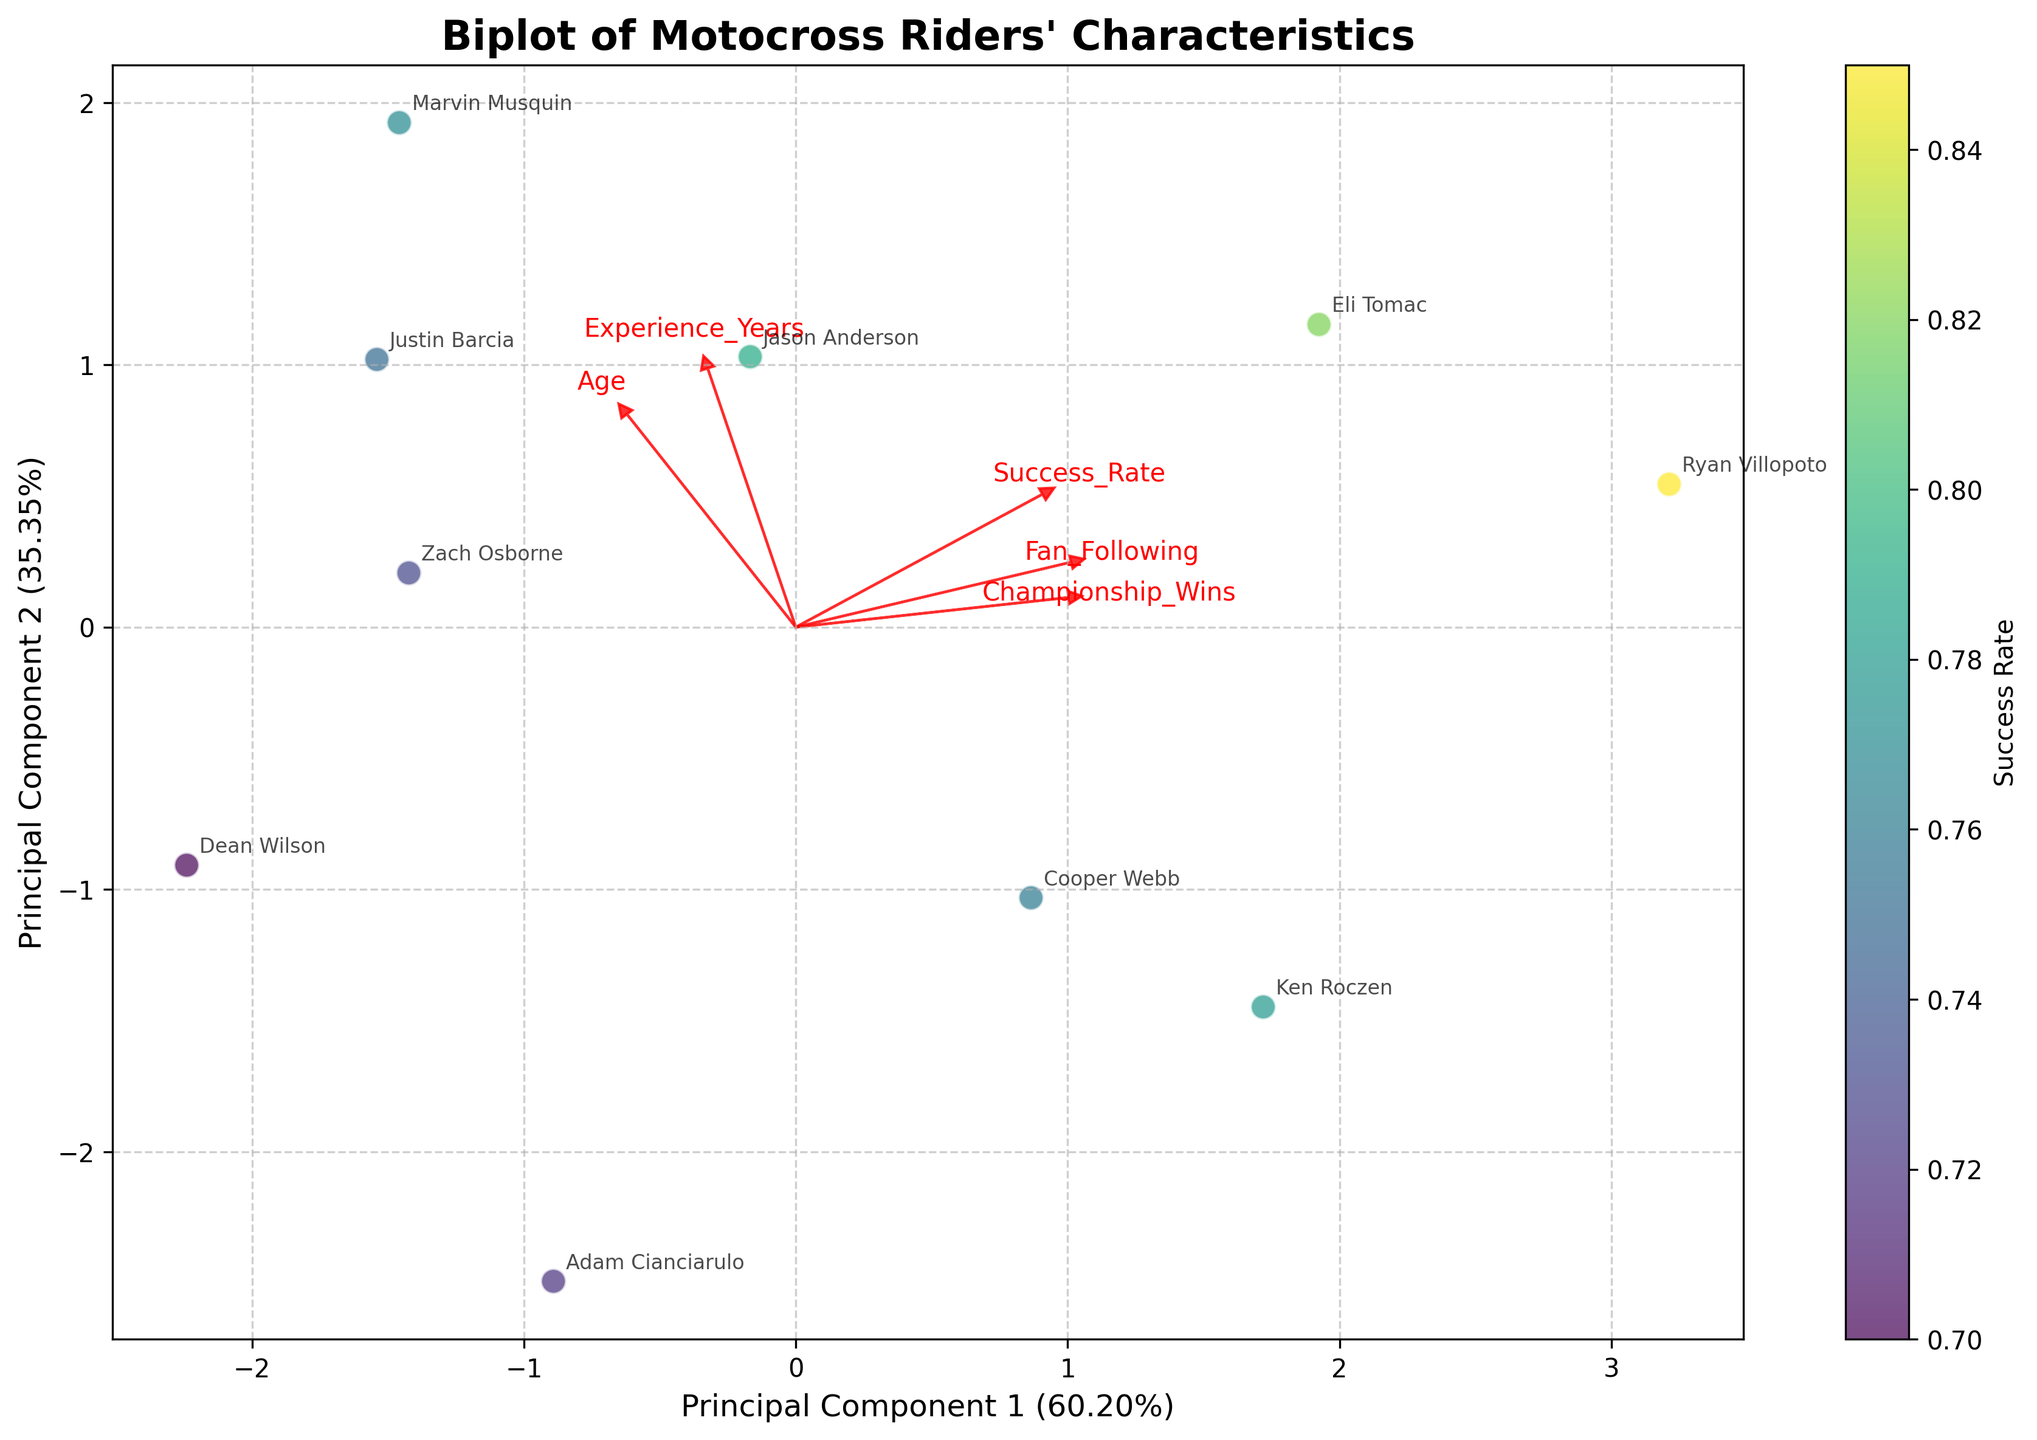What's the title of the figure? The title is typically placed at the top of the figure. Reading the top part will give us the full title.
Answer: Biplot of Motocross Riders' Characteristics How many data points are shown in the plot? Each rider is represented by a single data point. Counting all the annotated names will give us the total number of data points. There are 10 riders listed in the data.
Answer: 10 Which rider has the highest success rate? Observing the color gradient, the brightest colored data point will represent the highest success rate. Looking at the rider names, it's important to identify the brightest one.
Answer: Ryan Villopoto What does the x-axis represent? The label on the x-axis gives a description of what Principal Component 1 represents, as well as the percentage of variance it explains.
Answer: Principal Component 1 What feature is represented by the red arrow pointing most horizontally? The direction of the arrow indicates alignment with certain features. The horizontally longest arrow needs to be checked for the text beside it.
Answer: Fan Following Which two riders are closest to each other in the PCA-transformed space? By comparing the distance between each pair of data points, the visually shortest distance will reveal the closest riders.
Answer: Ken Roczen and Cooper Webb How does the experience level relate to the arrows' directions? By looking at the direction of the "Experience_Years" arrow, we can infer the relationship based on its angle in the PCA space.
Answer: Positively alongside PC1 and slightly along PC2 Considering the plot, what can be said about the relationship between "Age" and "Fan Following"? By comparing the angles and directions of the arrows representing "Age" and "Fan Following," one can deduce their correlation. They should either align or oppose each other.
Answer: Positive correlation Which feature explains the most variance in the direction of Principal Component 1? The loadings (arrows) that point most directly along the x-axis (Principal Component 1) and have significant length provide this information.
Answer: Age 